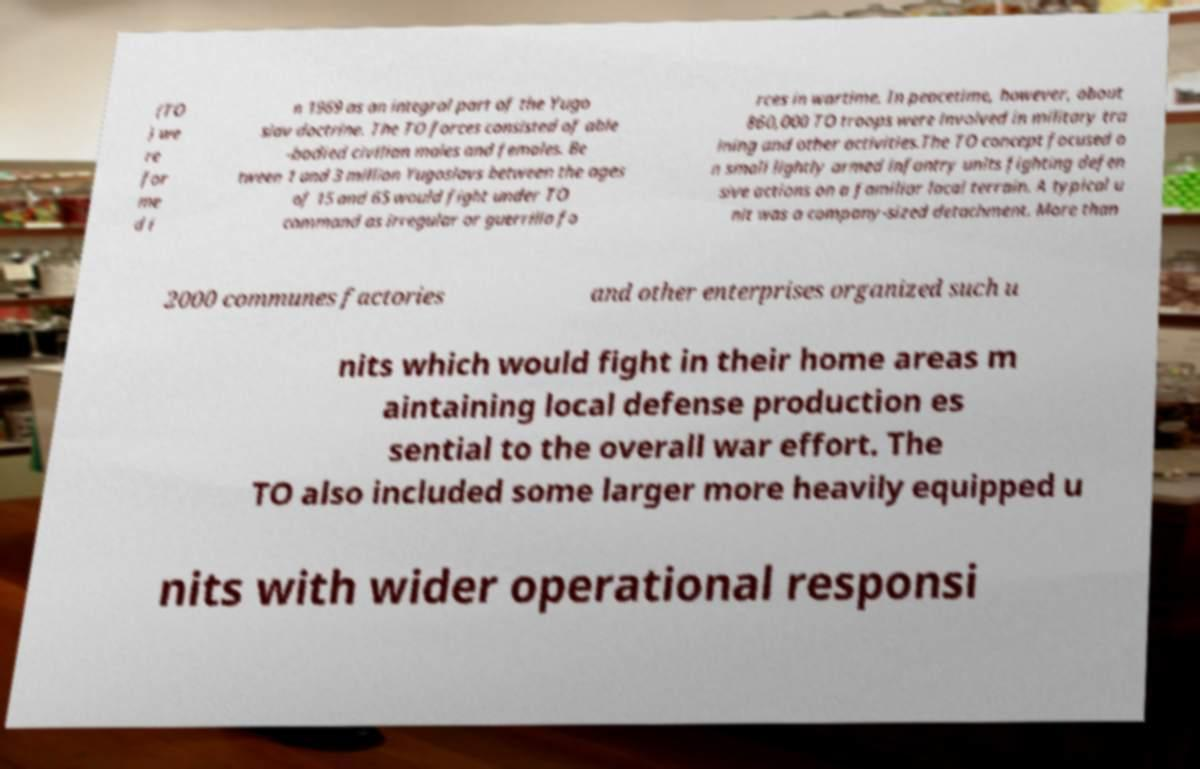What messages or text are displayed in this image? I need them in a readable, typed format. (TO ) we re for me d i n 1969 as an integral part of the Yugo slav doctrine. The TO forces consisted of able -bodied civilian males and females. Be tween 1 and 3 million Yugoslavs between the ages of 15 and 65 would fight under TO command as irregular or guerrilla fo rces in wartime. In peacetime, however, about 860,000 TO troops were involved in military tra ining and other activities.The TO concept focused o n small lightly armed infantry units fighting defen sive actions on a familiar local terrain. A typical u nit was a company-sized detachment. More than 2000 communes factories and other enterprises organized such u nits which would fight in their home areas m aintaining local defense production es sential to the overall war effort. The TO also included some larger more heavily equipped u nits with wider operational responsi 